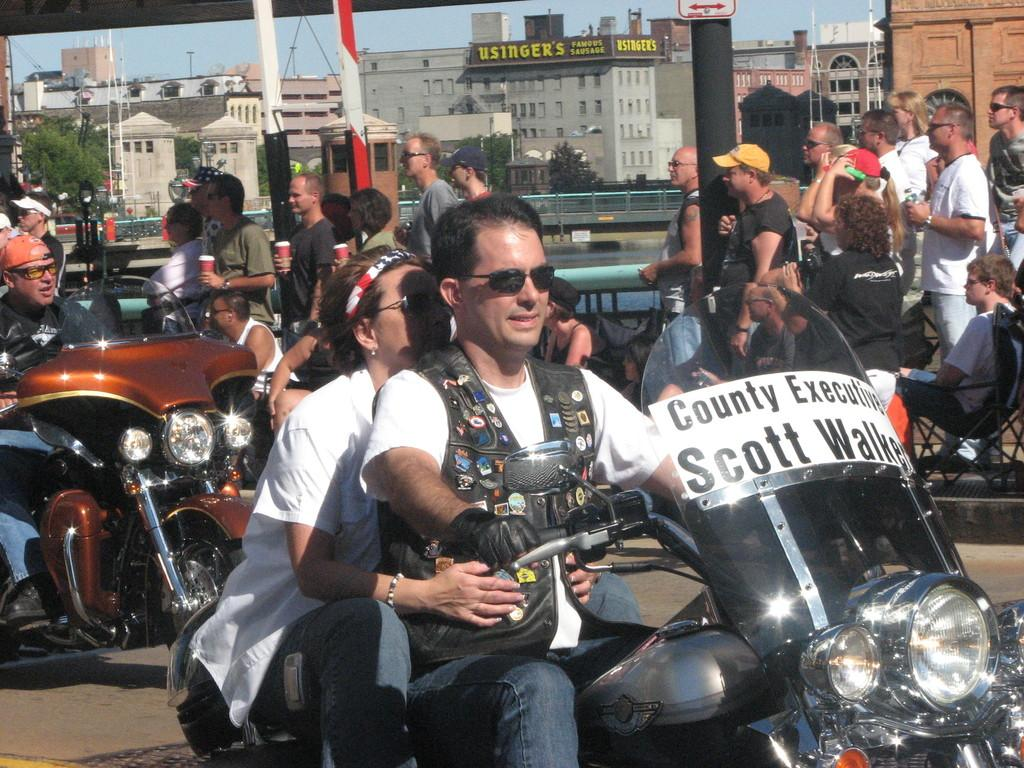Who is present in the image? There is a man and a woman in the image. What are they doing in the image? They are riding a bike. Where are they riding the bike? The bike is on a road. What else can be seen in the background of the image? There are other people visible in the background, as well as a car and a building. What type of pin is the woman holding in the image? There is no pin visible in the image. How many pieces of lumber can be seen stacked near the building in the background? There is no lumber present in the image. 